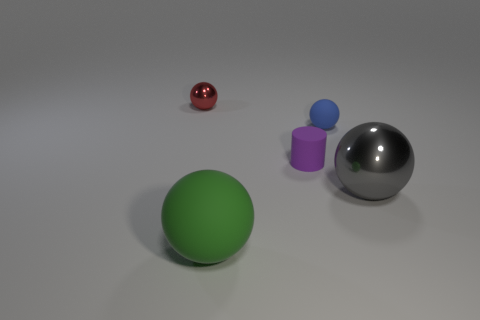Subtract all yellow spheres. Subtract all green cylinders. How many spheres are left? 4 Add 1 tiny purple things. How many objects exist? 6 Subtract all cylinders. How many objects are left? 4 Subtract all brown metallic blocks. Subtract all tiny red shiny balls. How many objects are left? 4 Add 4 large gray shiny spheres. How many large gray shiny spheres are left? 5 Add 5 tiny green matte spheres. How many tiny green matte spheres exist? 5 Subtract 0 purple blocks. How many objects are left? 5 